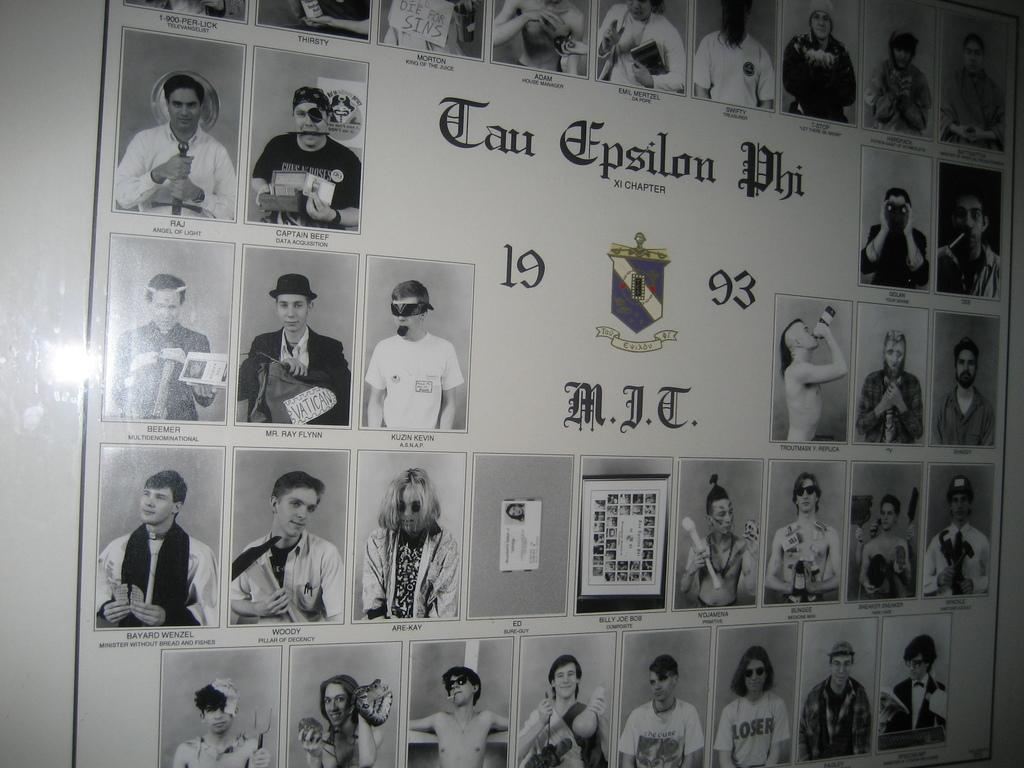What is hanging object can be seen on the wall in the image? There is a banner on the wall in the image. What is depicted on the banner? There are people depicted on the banner. What additional information is present on the banner? There is some information on the banner. How many brothers are depicted on the banner? There is no information about brothers on the banner; it only depicts people. 